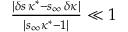Convert formula to latex. <formula><loc_0><loc_0><loc_500><loc_500>\begin{array} { r } { \frac { | \delta s \, \kappa ^ { * } - s _ { \infty } \, \delta \kappa | } { | s _ { \infty } \kappa ^ { * } - 1 | } \ll 1 } \end{array}</formula> 